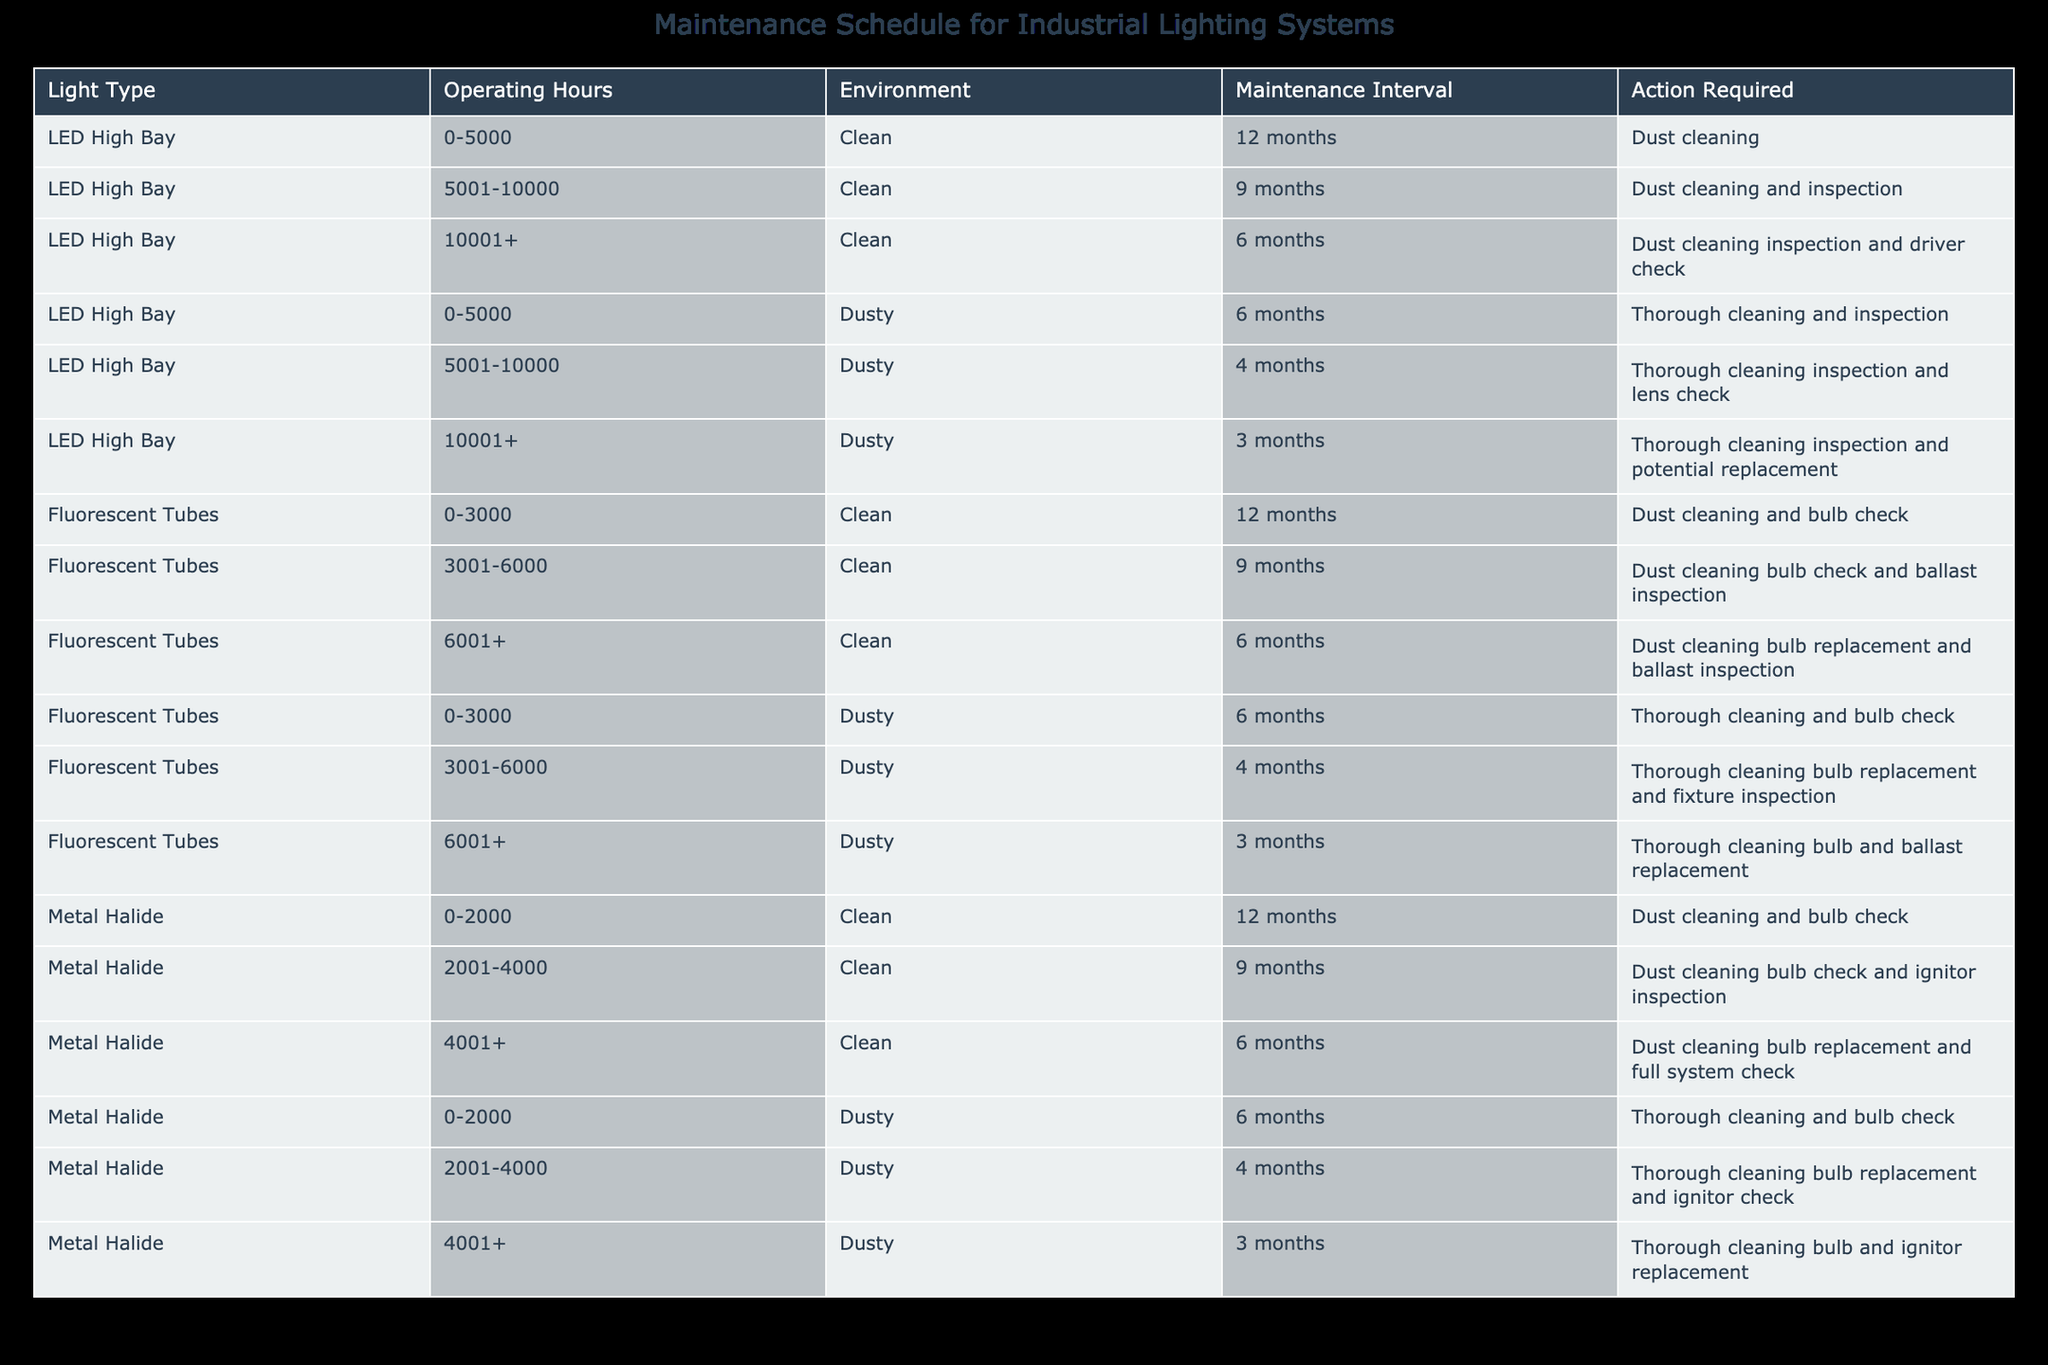What is the maintenance interval for LED High Bay lights operating between 5001 and 10000 hours in a clean environment? According to the table, the maintenance interval for LED High Bay lights operating between 5001 and 10000 hours in a clean environment is specified as 9 months.
Answer: 9 months What action is required for Fluorescent Tubes that operate more than 6001 hours in a dusty environment? The table indicates that for Fluorescent Tubes operating more than 6001 hours in a dusty environment, the action required is thorough cleaning, bulb and ballast replacement.
Answer: Thorough cleaning, bulb and ballast replacement How often should Metal Halide lights that have operated for 2001 to 4000 hours in a dusty environment be maintained? The table specifies that Metal Halide lights operating for 2001 to 4000 hours in a dusty environment should be maintained every 4 months.
Answer: 4 months Are LED High Bay lights maintained more frequently than Fluorescent Tubes operating in a clean environment? To answer this, we can look at the maintenance intervals. LED High Bay lights operating between 5001 and 10000 hours have a maintenance interval of 9 months while Fluorescent Tubes operating for 3001 to 6000 hours have a maintenance interval of 9 months. Hence, they are maintained at the same frequency in this case.
Answer: No What is the difference in maintenance intervals between LED High Bay lights operating 10001+ hours in a clean versus a dusty environment? We first check the maintenance interval for LED High Bay lights in a clean environment (6 months for over 10001 hours) and in a dusty environment (3 months for over 10001 hours). The difference is 6 months - 3 months = 3 months.
Answer: 3 months What total number of actions are required for LED High Bay lights operating between 0-5000 hours in dusty conditions? For LED High Bay lights in this category, the required action is "thorough cleaning and inspection". Hence, it indicates one action which is a combined action.
Answer: One action For how many types of lights is the maintenance interval shorter in a dusty environment compared to a clean environment at 4001+ operating hours? Checking the table, Metal Halide lights have a shorter maintenance interval in dusty conditions (3 months) compared to clean (6 months) while LED High Bay lights maintain the same interval (6 months in clean vs. 3 months in dusty). Therefore, there is one category (Metal Halide) with this condition.
Answer: One type Do all maintenance actions require inspection for Metal Halide lights that have operated for more than 2000 hours in a clean environment? By examining the table, the actions required for Metal Halide lights over 2000 hours in a clean environment include inspections at different intervals: 9 months specifies an ignitor inspection only. Hence, not all actions require inspection.
Answer: No 